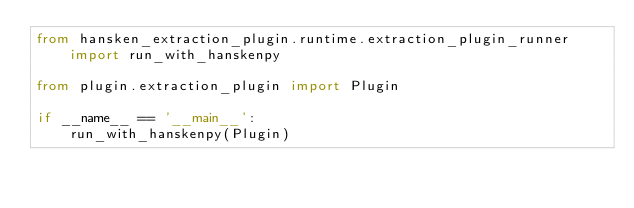Convert code to text. <code><loc_0><loc_0><loc_500><loc_500><_Python_>from hansken_extraction_plugin.runtime.extraction_plugin_runner import run_with_hanskenpy

from plugin.extraction_plugin import Plugin

if __name__ == '__main__':
    run_with_hanskenpy(Plugin)
</code> 